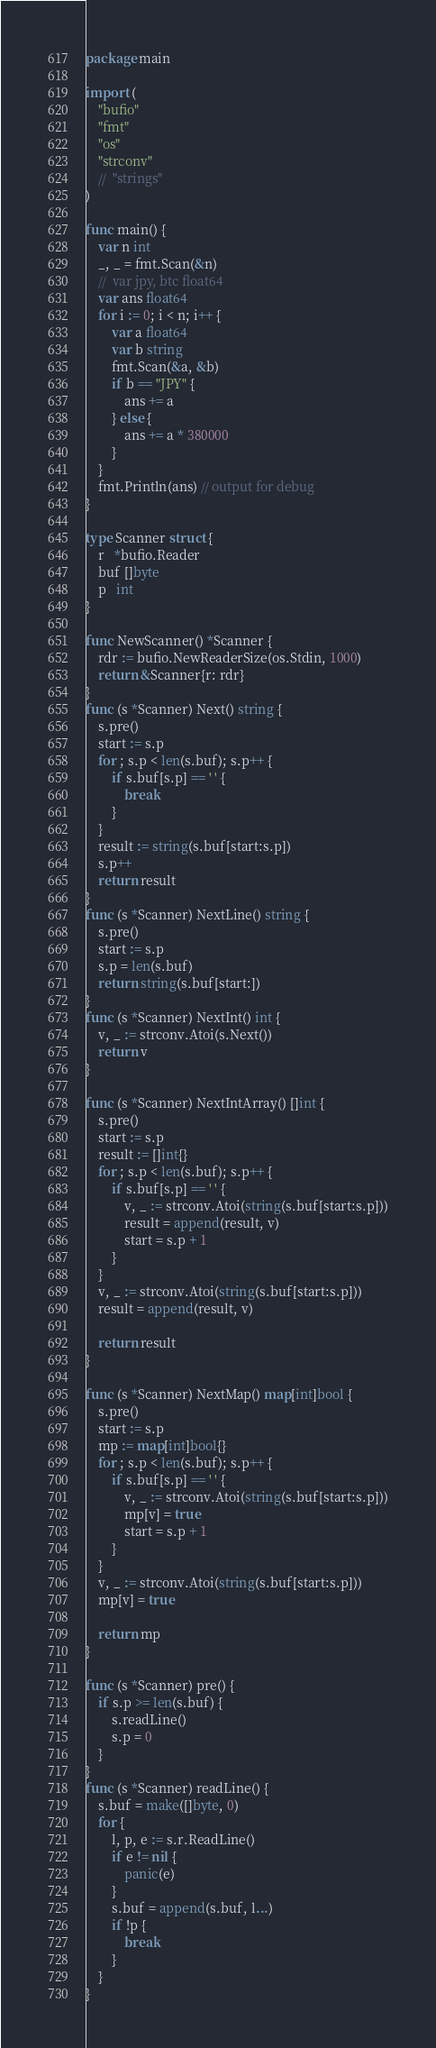<code> <loc_0><loc_0><loc_500><loc_500><_Go_>package main

import (
	"bufio"
	"fmt"
	"os"
	"strconv"
	//	"strings"
)

func main() {
	var n int
	_, _ = fmt.Scan(&n)
	//	var jpy, btc float64
	var ans float64
	for i := 0; i < n; i++ {
		var a float64
		var b string
		fmt.Scan(&a, &b)
		if b == "JPY" {
			ans += a
		} else {
			ans += a * 380000
		}
	}
	fmt.Println(ans) // output for debug
}

type Scanner struct {
	r   *bufio.Reader
	buf []byte
	p   int
}

func NewScanner() *Scanner {
	rdr := bufio.NewReaderSize(os.Stdin, 1000)
	return &Scanner{r: rdr}
}
func (s *Scanner) Next() string {
	s.pre()
	start := s.p
	for ; s.p < len(s.buf); s.p++ {
		if s.buf[s.p] == ' ' {
			break
		}
	}
	result := string(s.buf[start:s.p])
	s.p++
	return result
}
func (s *Scanner) NextLine() string {
	s.pre()
	start := s.p
	s.p = len(s.buf)
	return string(s.buf[start:])
}
func (s *Scanner) NextInt() int {
	v, _ := strconv.Atoi(s.Next())
	return v
}

func (s *Scanner) NextIntArray() []int {
	s.pre()
	start := s.p
	result := []int{}
	for ; s.p < len(s.buf); s.p++ {
		if s.buf[s.p] == ' ' {
			v, _ := strconv.Atoi(string(s.buf[start:s.p]))
			result = append(result, v)
			start = s.p + 1
		}
	}
	v, _ := strconv.Atoi(string(s.buf[start:s.p]))
	result = append(result, v)

	return result
}

func (s *Scanner) NextMap() map[int]bool {
	s.pre()
	start := s.p
	mp := map[int]bool{}
	for ; s.p < len(s.buf); s.p++ {
		if s.buf[s.p] == ' ' {
			v, _ := strconv.Atoi(string(s.buf[start:s.p]))
			mp[v] = true
			start = s.p + 1
		}
	}
	v, _ := strconv.Atoi(string(s.buf[start:s.p]))
	mp[v] = true

	return mp
}

func (s *Scanner) pre() {
	if s.p >= len(s.buf) {
		s.readLine()
		s.p = 0
	}
}
func (s *Scanner) readLine() {
	s.buf = make([]byte, 0)
	for {
		l, p, e := s.r.ReadLine()
		if e != nil {
			panic(e)
		}
		s.buf = append(s.buf, l...)
		if !p {
			break
		}
	}
}
</code> 